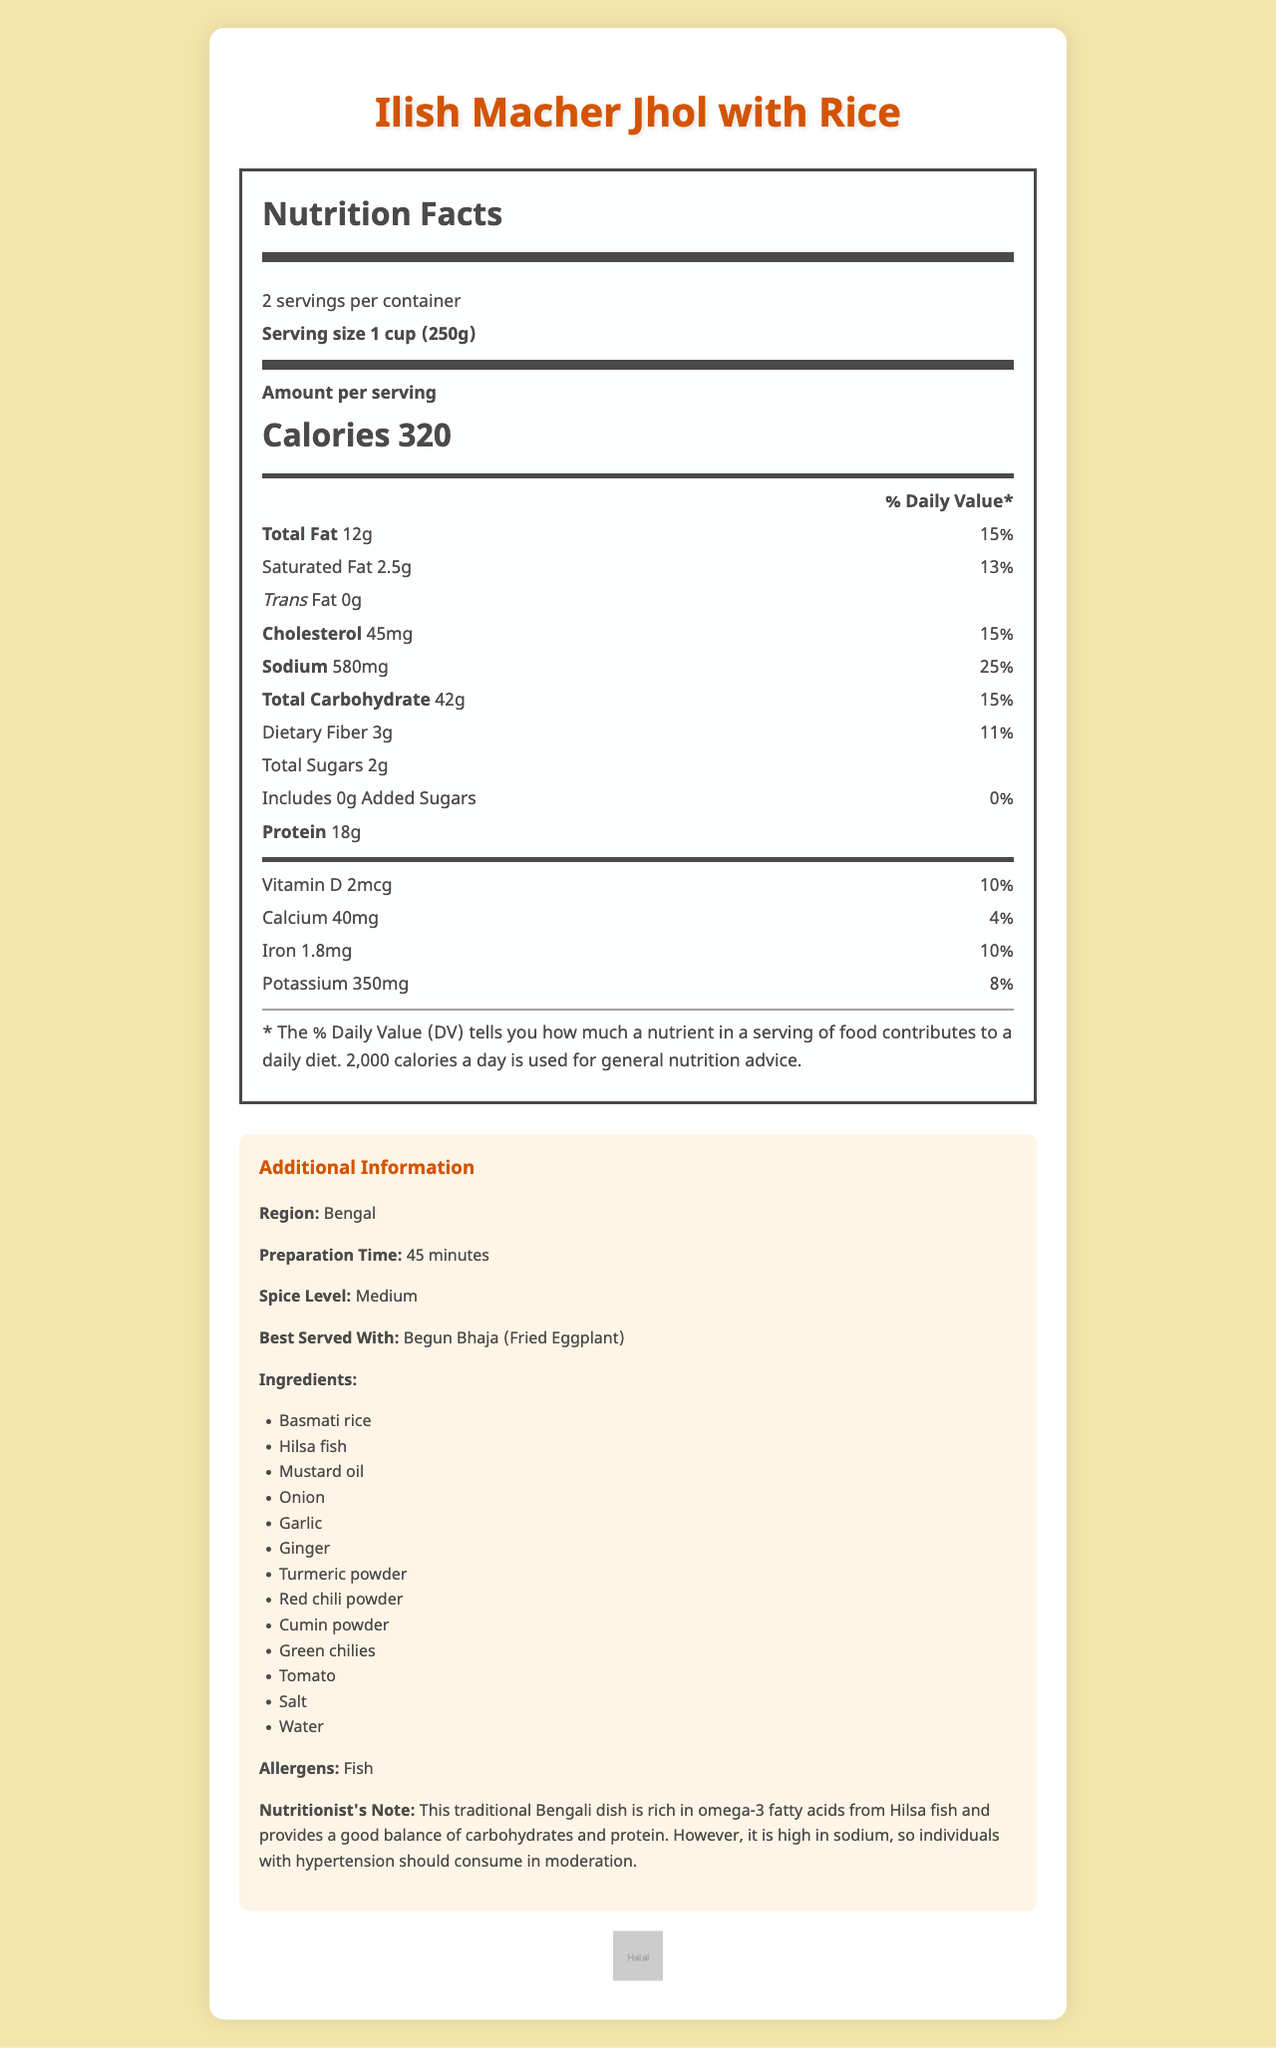what is the serving size? The serving size is listed at the top of the Nutrition Facts label.
Answer: 1 cup (250g) how many servings are there per container? This information is provided near the top of the Nutrition Facts label.
Answer: 2 servings per container how many calories are there per serving? The amount of calories per serving is prominently displayed.
Answer: 320 calories what is the total fat content per serving? The total fat content per serving is listed under the "Total Fat" section.
Answer: 12 grams what is the percentage of the daily value for sodium? The percentage of the daily value for sodium is listed next to the sodium content.
Answer: 25% Based on the document, which ingredient is likely to contain high omega-3 fatty acids? A. Mustard oil B. Garlic C. Hilsa fish D. Basmati rice The document specifically mentions that Hilsa fish is rich in omega-3 fatty acids in the nutritionist's note.
Answer: C. Hilsa fish What is the cholesterol content per serving? A. 30 mg B. 45 mg C. 60 mg D. 25 mg The cholesterol content per serving is listed as 45 mg next to its name.
Answer: B. 45 mg Does the dish contain any trans fat? The trans fat amount is listed as 0 grams in the document.
Answer: No Is this dish certified as halal? The "certifications" section at the bottom of the document lists "Halal".
Answer: Yes Summarize the main nutritional benefits and concerns of the dish. The nutritionist's note mentions the dish is rich in omega-3 fatty acids, provides a good balance of carbohydrates and protein, but is high in sodium.
Answer: Rich in omega-3 fatty acids, balanced in carbohydrates and protein, high in sodium Can you list all the ingredients used in the dish? Ingredients listed: Basmati rice, Hilsa fish, Mustard oil, Onion, Garlic, Ginger, Turmeric powder, Red chili powder, Cumin powder, Green chilies, Tomato, Salt, Water.
Answer: Yes How much vitamin D does each serving provide? The vitamin D content per serving is listed as 2 mcg.
Answer: 2 mcg What is the recommended accompaniment for this dish? The "additionalInfo" section mentions that the dish is best served with Begun Bhaja.
Answer: Begun Bhaja (Fried Eggplant) What is the preparation time for this dish? The "additionalInfo" section lists the preparation time as 45 minutes.
Answer: 45 minutes Does the document specify the sugar content? If so, what is it? The nutrition label lists 2 grams of total sugars and 0 grams of added sugars.
Answer: Yes, 2 grams of total sugars and 0 grams of added sugars What is the total carbohydrate content in one serving? The total carbohydrate content per serving is listed in the nutrition label section.
Answer: 42 grams What is the daily value percentage for dietary fiber? The percentage of the daily value for dietary fiber is listed next to its amount.
Answer: 11% What is the spice level of the dish as listed in the document? The "additionalInfo" section states the spice level as "Medium".
Answer: Medium Where is this dish commonly found or originated from? The "additionalInfo" section lists the region as Bengal.
Answer: Bengal How much protein does each serving contain? The protein content per serving is listed in the nutrition facts section.
Answer: 18 grams How much potassium is present per serving of this dish? The potassium content per serving is listed as 350 mg.
Answer: 350 mg Does the document mention if the dish contains dairy? The document lists the ingredients and allergens, but there is no mention of dairy specifically.
Answer: Not enough information 